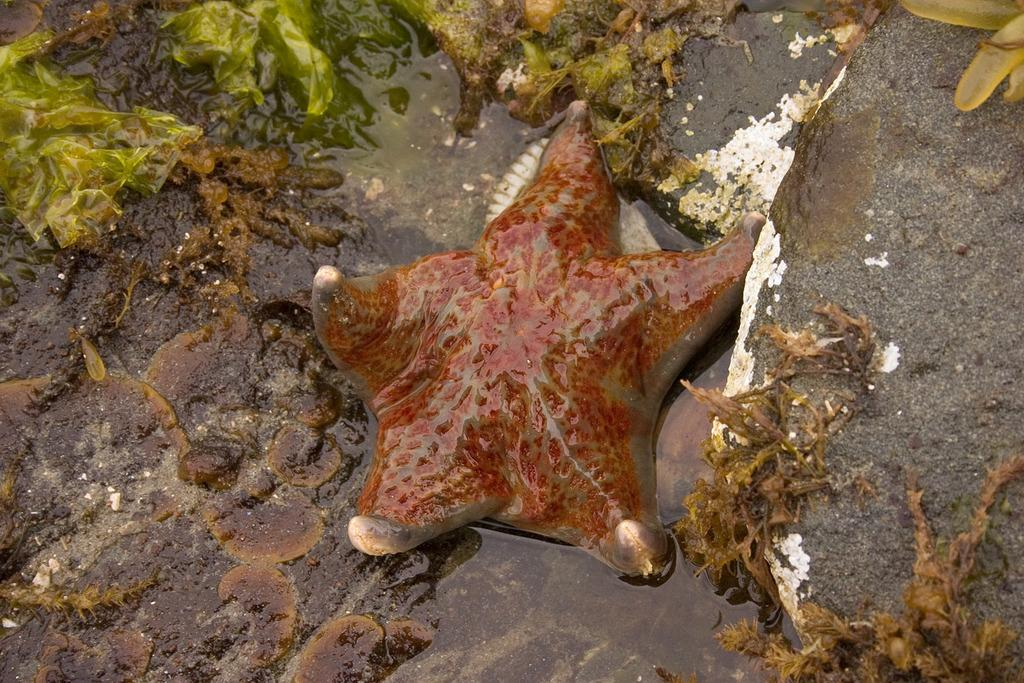What type of marine animal is present in the image? There is a starfish in the image. Can you describe the water in the image? The water is muddy. How many apples are hanging from the trees in the image? There are no trees or apples present in the image; it features a starfish in muddy water. What force is acting on the starfish in the image? There is no specific force acting on the starfish in the image; it is simply resting in the muddy water. 